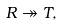Convert formula to latex. <formula><loc_0><loc_0><loc_500><loc_500>R \twoheadrightarrow T ,</formula> 